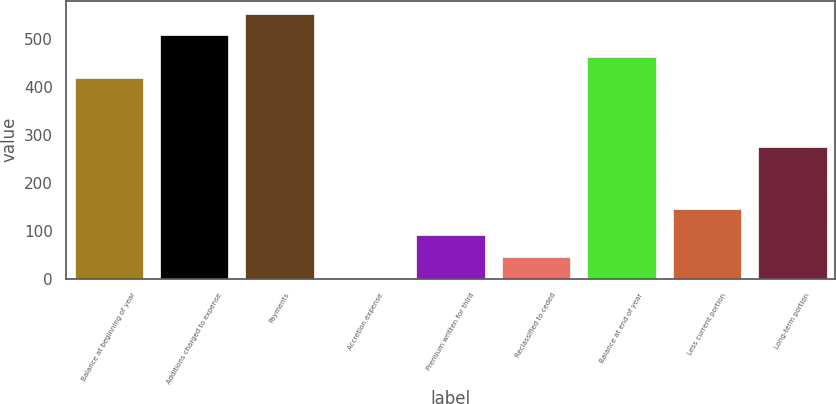Convert chart. <chart><loc_0><loc_0><loc_500><loc_500><bar_chart><fcel>Balance at beginning of year<fcel>Additions charged to expense<fcel>Payments<fcel>Accretion expense<fcel>Premium written for third<fcel>Reclassified to ceded<fcel>Balance at end of year<fcel>Less current portion<fcel>Long-term portion<nl><fcel>418.5<fcel>507.86<fcel>552.54<fcel>1.2<fcel>90.56<fcel>45.88<fcel>463.18<fcel>144.8<fcel>275.4<nl></chart> 